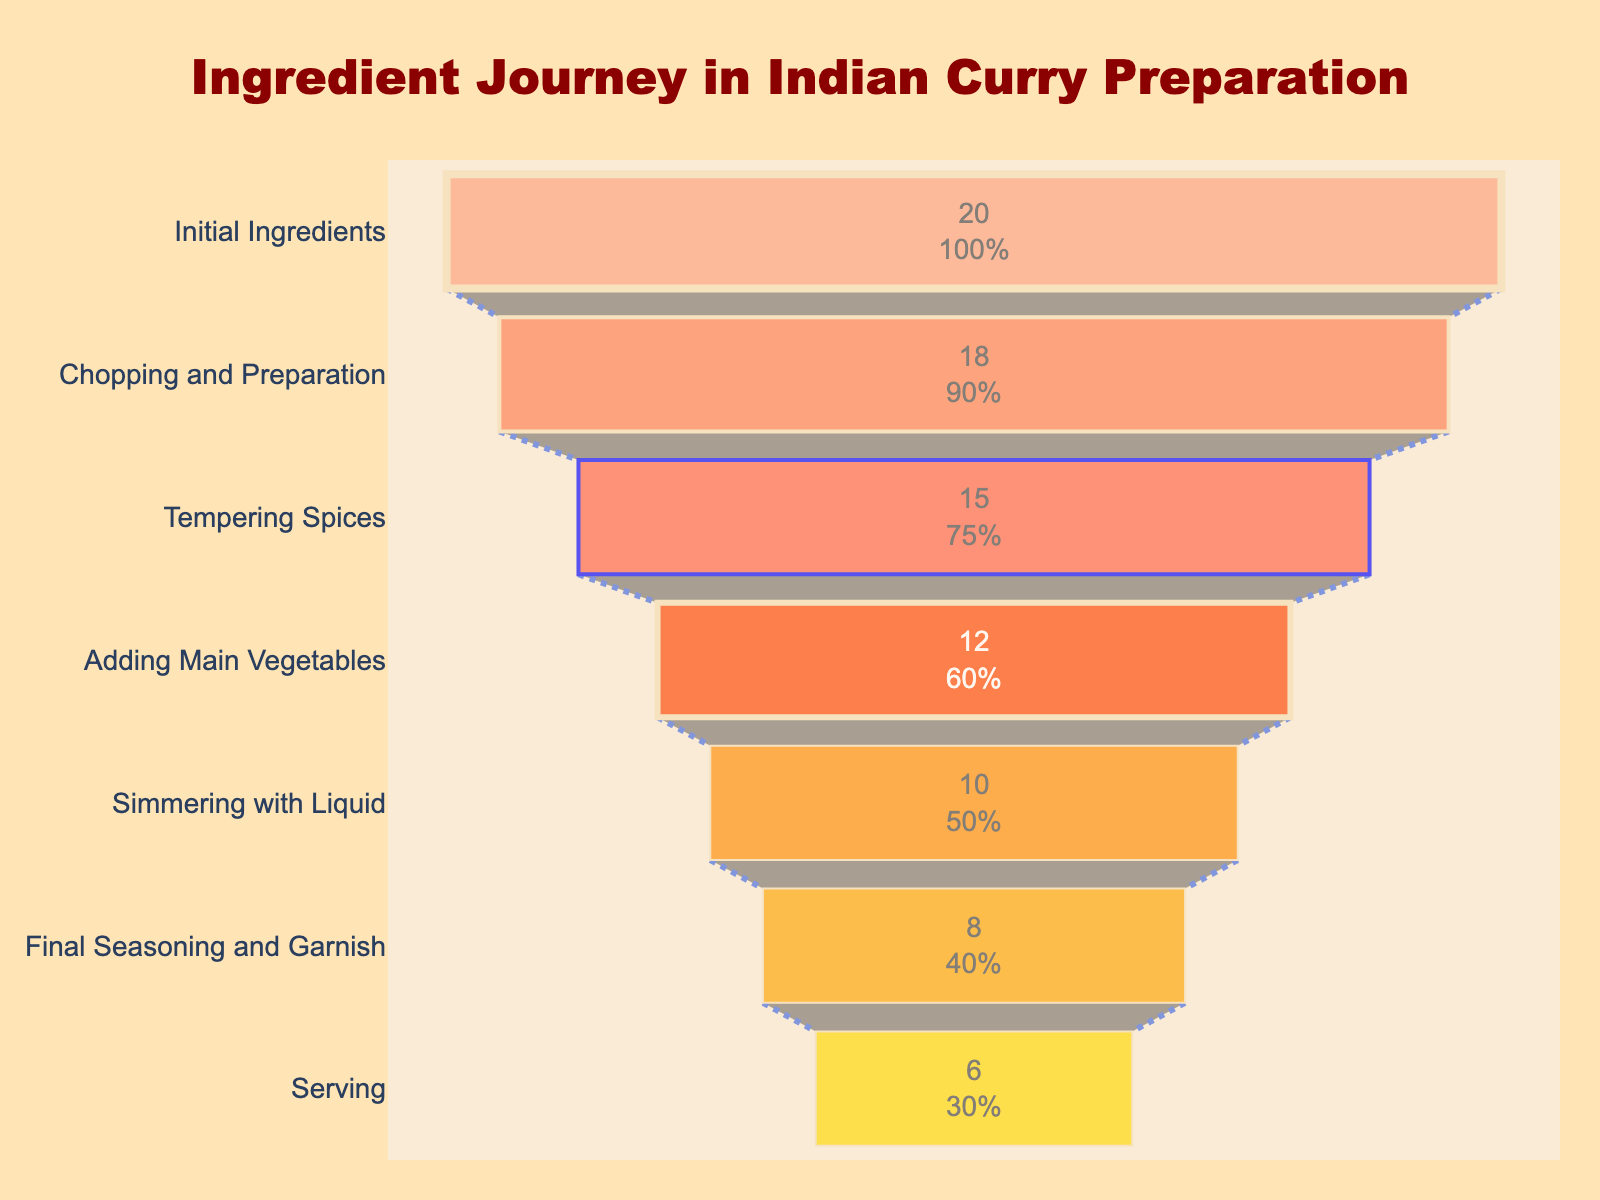What is the title of the funnel chart? The title of the funnel chart is located at the top center of the plot and is usually larger and bolder than other text elements.
Answer: Ingredient Journey in Indian Curry Preparation How many stages are involved in preparing the traditional Indian curry? The number of stages can be counted on the y-axis, where each stage name is listed.
Answer: 7 At which stage do you see the largest reduction in the number of ingredients? Compare the differences between successive stages and identify the largest drop. The biggest reduction happens between the initial ingredients and chopping and preparation, where the reduction is 2 ingredients.
Answer: Initial Ingredients to Chopping and Preparation What percentage of the initial ingredients remain after the simmering with liquid stage? Look at the text information inside the funnel segment for Simmering with Liquid and note the percentage indicated.
Answer: 50% How many ingredients are left at the final seasoning and garnish stage? Identify the segment labeled "Final Seasoning and Garnish" and read the number of ingredients remaining.
Answer: 8 Which stage has the smallest number of remaining ingredients? Look at the x-axis values for all stages and find the smallest number.
Answer: Serving Compare the number of ingredients remaining after tempering spices to the number of ingredients remaining after adding main vegetables. Find the values corresponding to each stage and subtract the values: 15 (Tempering Spices) - 12 (Adding Main Vegetables) = 3
Answer: 3 What is the color of the segment for the stage "Adding Main Vegetables"? Identify the color of the section labeled "Adding Main Vegetables" on the funnel chart.
Answer: Orange How does the number of ingredients change from simmering with liquid to final seasoning and garnish? Calculate the change by subtracting the values for these stages: 10 (Simmering with Liquid) - 8 (Final Seasoning and Garnish) = 2
Answer: Decreases by 2 Estimate the total reduction in ingredients from the initial stage to the final stage. Subtract the number of ingredients at the final stage from the initial stage: 20 (Initial Ingredients) - 6 (Serving) = 14
Answer: 14 